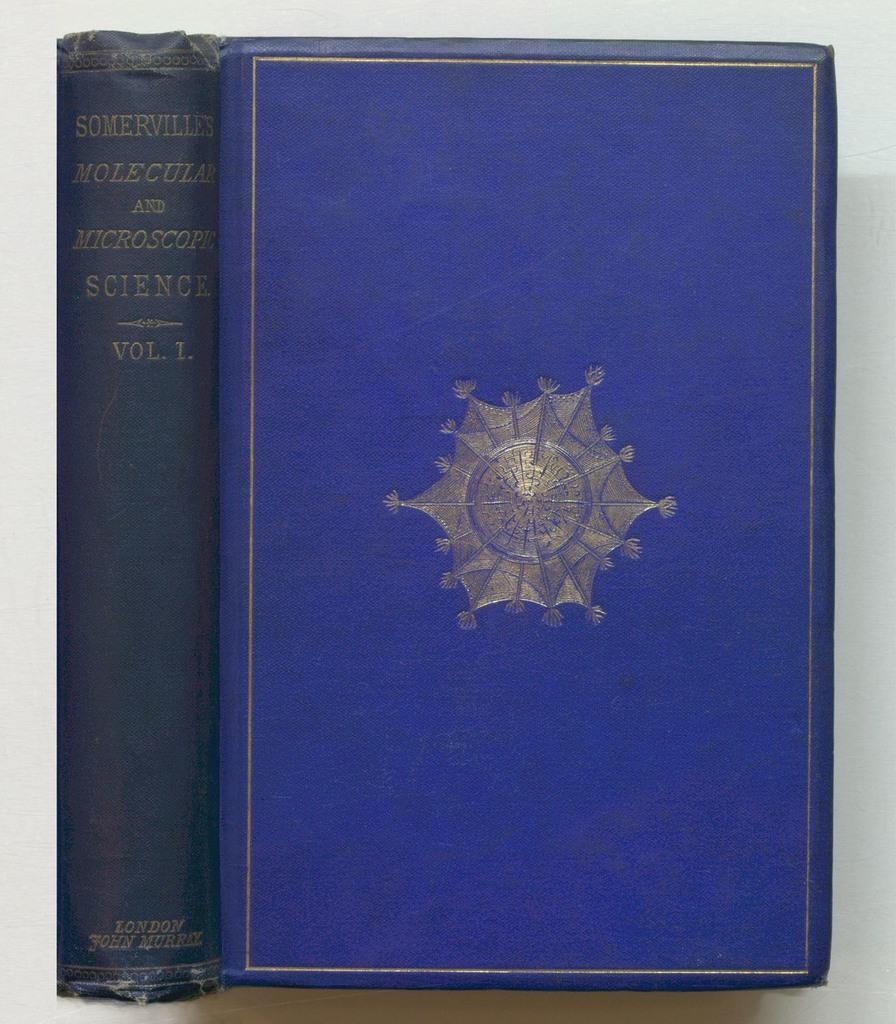<image>
Share a concise interpretation of the image provided. A two view close up of a old looking book called Somervilles Molecular and Microscope science. 